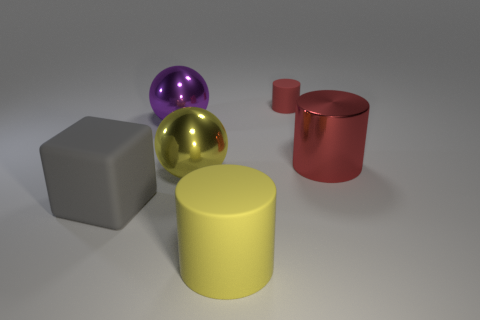Does the big red thing have the same material as the object in front of the cube?
Give a very brief answer. No. There is another large object that is the same shape as the big yellow shiny object; what material is it?
Keep it short and to the point. Metal. Are there any other things that are made of the same material as the gray cube?
Keep it short and to the point. Yes. Does the cylinder left of the small thing have the same material as the big cylinder that is behind the yellow rubber thing?
Keep it short and to the point. No. There is a big object right of the rubber cylinder that is in front of the cylinder behind the big purple thing; what color is it?
Your answer should be very brief. Red. What number of other objects are the same shape as the gray matte thing?
Your answer should be compact. 0. Is the rubber block the same color as the large matte cylinder?
Give a very brief answer. No. What number of objects are yellow things or yellow things that are in front of the large gray matte object?
Keep it short and to the point. 2. Are there any other cubes of the same size as the rubber cube?
Provide a short and direct response. No. Do the large red cylinder and the small cylinder have the same material?
Offer a terse response. No. 